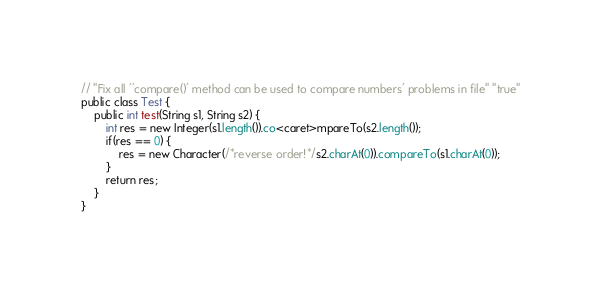Convert code to text. <code><loc_0><loc_0><loc_500><loc_500><_Java_>// "Fix all ''compare()' method can be used to compare numbers' problems in file" "true"
public class Test {
    public int test(String s1, String s2) {
        int res = new Integer(s1.length()).co<caret>mpareTo(s2.length());
        if(res == 0) {
            res = new Character(/*reverse order!*/s2.charAt(0)).compareTo(s1.charAt(0));
        }
        return res;
    }
}</code> 